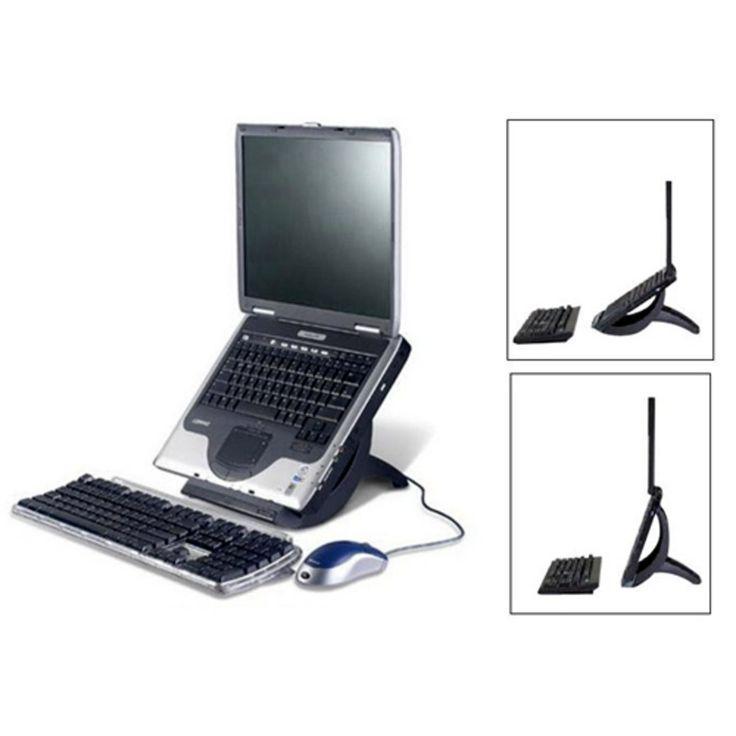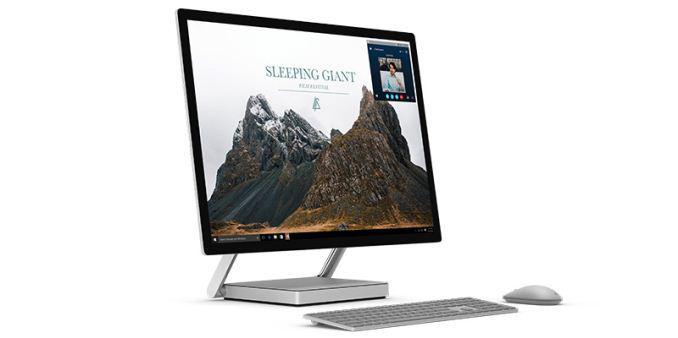The first image is the image on the left, the second image is the image on the right. Analyze the images presented: Is the assertion "In at least one image there is a silver bottomed laptop with a detachable mouse to the right." valid? Answer yes or no. Yes. The first image is the image on the left, the second image is the image on the right. Assess this claim about the two images: "One image shows an open laptop with its keyboard base attached and sitting flat, and the other image includes at least one screen propped up like an easel with a keyboard in front of it that does not appear to be attached.". Correct or not? Answer yes or no. No. 